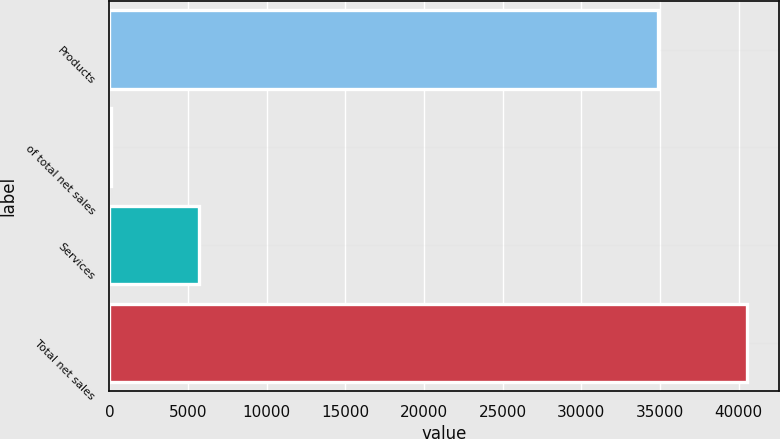Convert chart to OTSL. <chart><loc_0><loc_0><loc_500><loc_500><bar_chart><fcel>Products<fcel>of total net sales<fcel>Services<fcel>Total net sales<nl><fcel>34868<fcel>86<fcel>5668<fcel>40536<nl></chart> 